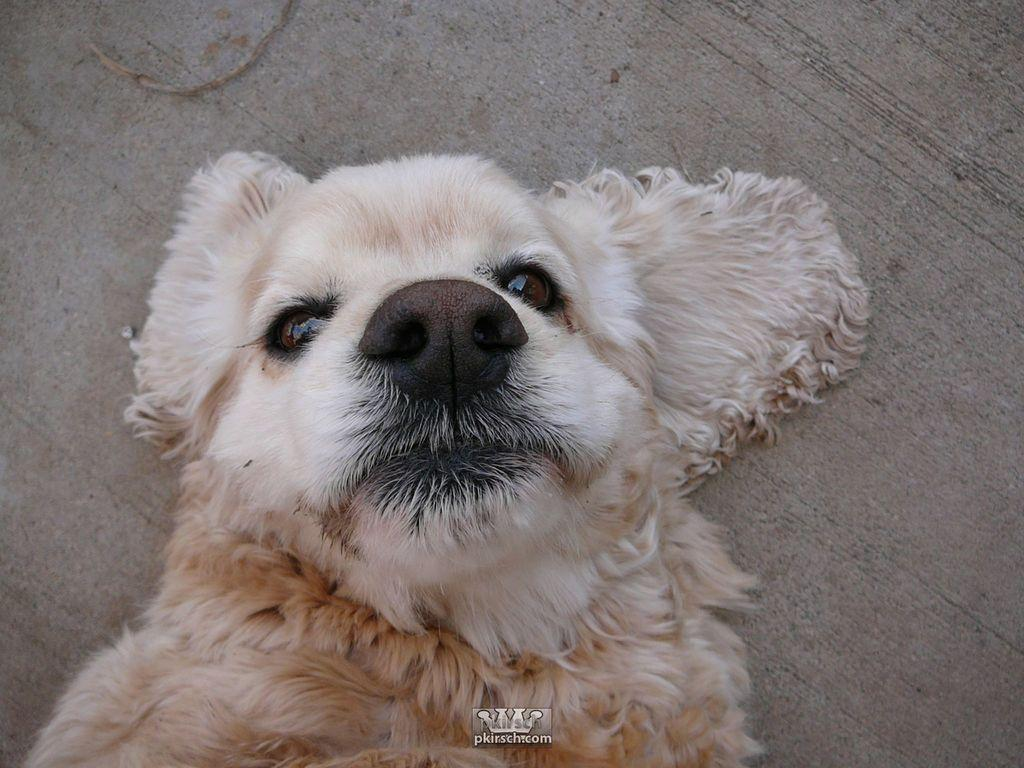What animal is in the image? There is a dog in the image. Where is the dog located in the image? The dog is in the front of the image. What can be found at the bottom of the image? There is a logo and some text at the bottom of the image. How does the dog attack the water in the image? There is no water present in the image, and the dog is not attacking anything. 